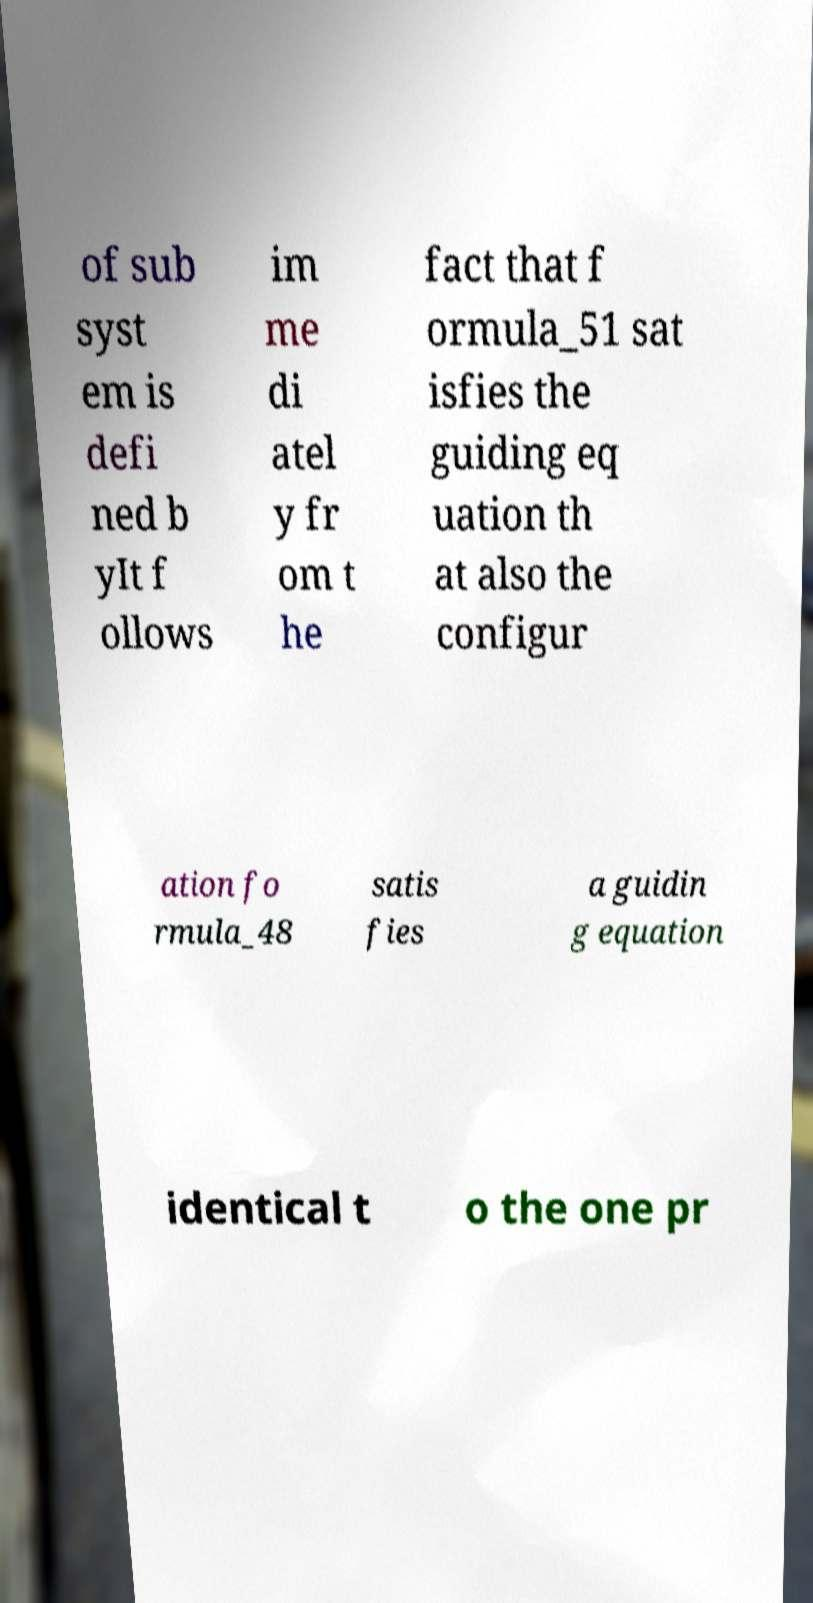Can you accurately transcribe the text from the provided image for me? of sub syst em is defi ned b yIt f ollows im me di atel y fr om t he fact that f ormula_51 sat isfies the guiding eq uation th at also the configur ation fo rmula_48 satis fies a guidin g equation identical t o the one pr 